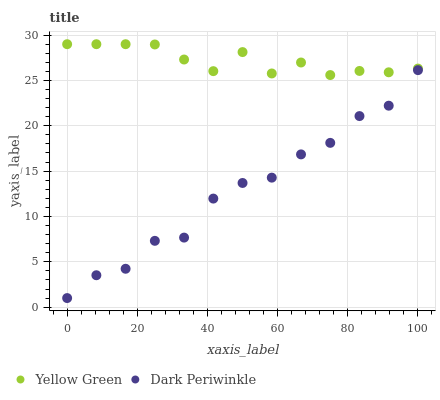Does Dark Periwinkle have the minimum area under the curve?
Answer yes or no. Yes. Does Yellow Green have the maximum area under the curve?
Answer yes or no. Yes. Does Dark Periwinkle have the maximum area under the curve?
Answer yes or no. No. Is Yellow Green the smoothest?
Answer yes or no. Yes. Is Dark Periwinkle the roughest?
Answer yes or no. Yes. Is Dark Periwinkle the smoothest?
Answer yes or no. No. Does Dark Periwinkle have the lowest value?
Answer yes or no. Yes. Does Yellow Green have the highest value?
Answer yes or no. Yes. Does Dark Periwinkle have the highest value?
Answer yes or no. No. Is Dark Periwinkle less than Yellow Green?
Answer yes or no. Yes. Is Yellow Green greater than Dark Periwinkle?
Answer yes or no. Yes. Does Dark Periwinkle intersect Yellow Green?
Answer yes or no. No. 